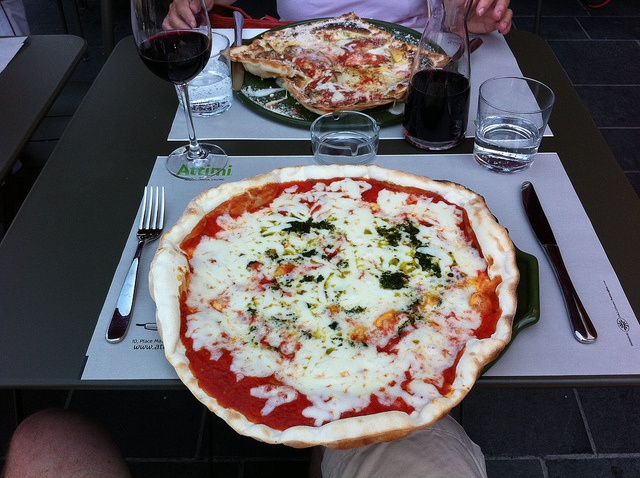Describe the objects in this image and their specific colors. I can see dining table in black, darkgray, and lightgray tones, pizza in black, lightgray, darkgray, maroon, and tan tones, people in black, gray, maroon, and brown tones, pizza in black, brown, darkgray, maroon, and gray tones, and cup in black, gray, and maroon tones in this image. 